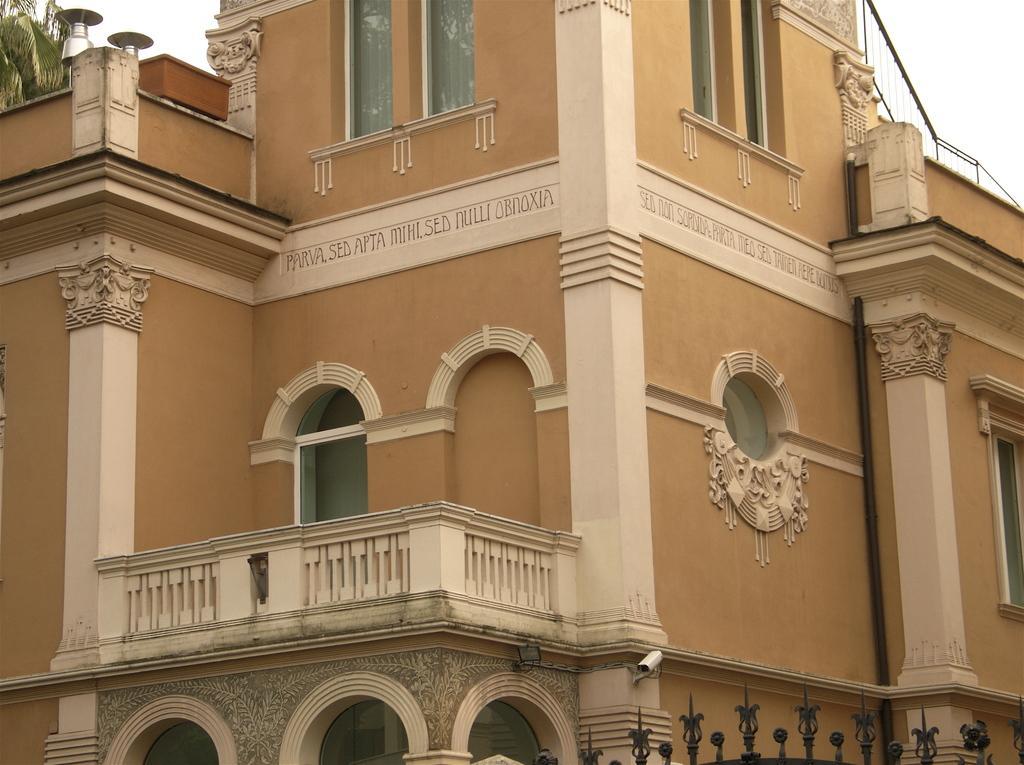Please provide a concise description of this image. In this picture we can see a building, windows, balcony. There is something written on the walls of a building. On the right side of the picture we can see a railing. On the left side of the picture it looks like a tree. At the bottom portion of the picture it looks like the top portion of an iron gate. 